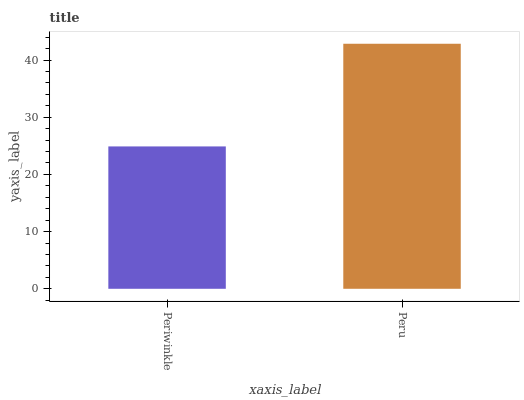Is Periwinkle the minimum?
Answer yes or no. Yes. Is Peru the maximum?
Answer yes or no. Yes. Is Peru the minimum?
Answer yes or no. No. Is Peru greater than Periwinkle?
Answer yes or no. Yes. Is Periwinkle less than Peru?
Answer yes or no. Yes. Is Periwinkle greater than Peru?
Answer yes or no. No. Is Peru less than Periwinkle?
Answer yes or no. No. Is Peru the high median?
Answer yes or no. Yes. Is Periwinkle the low median?
Answer yes or no. Yes. Is Periwinkle the high median?
Answer yes or no. No. Is Peru the low median?
Answer yes or no. No. 